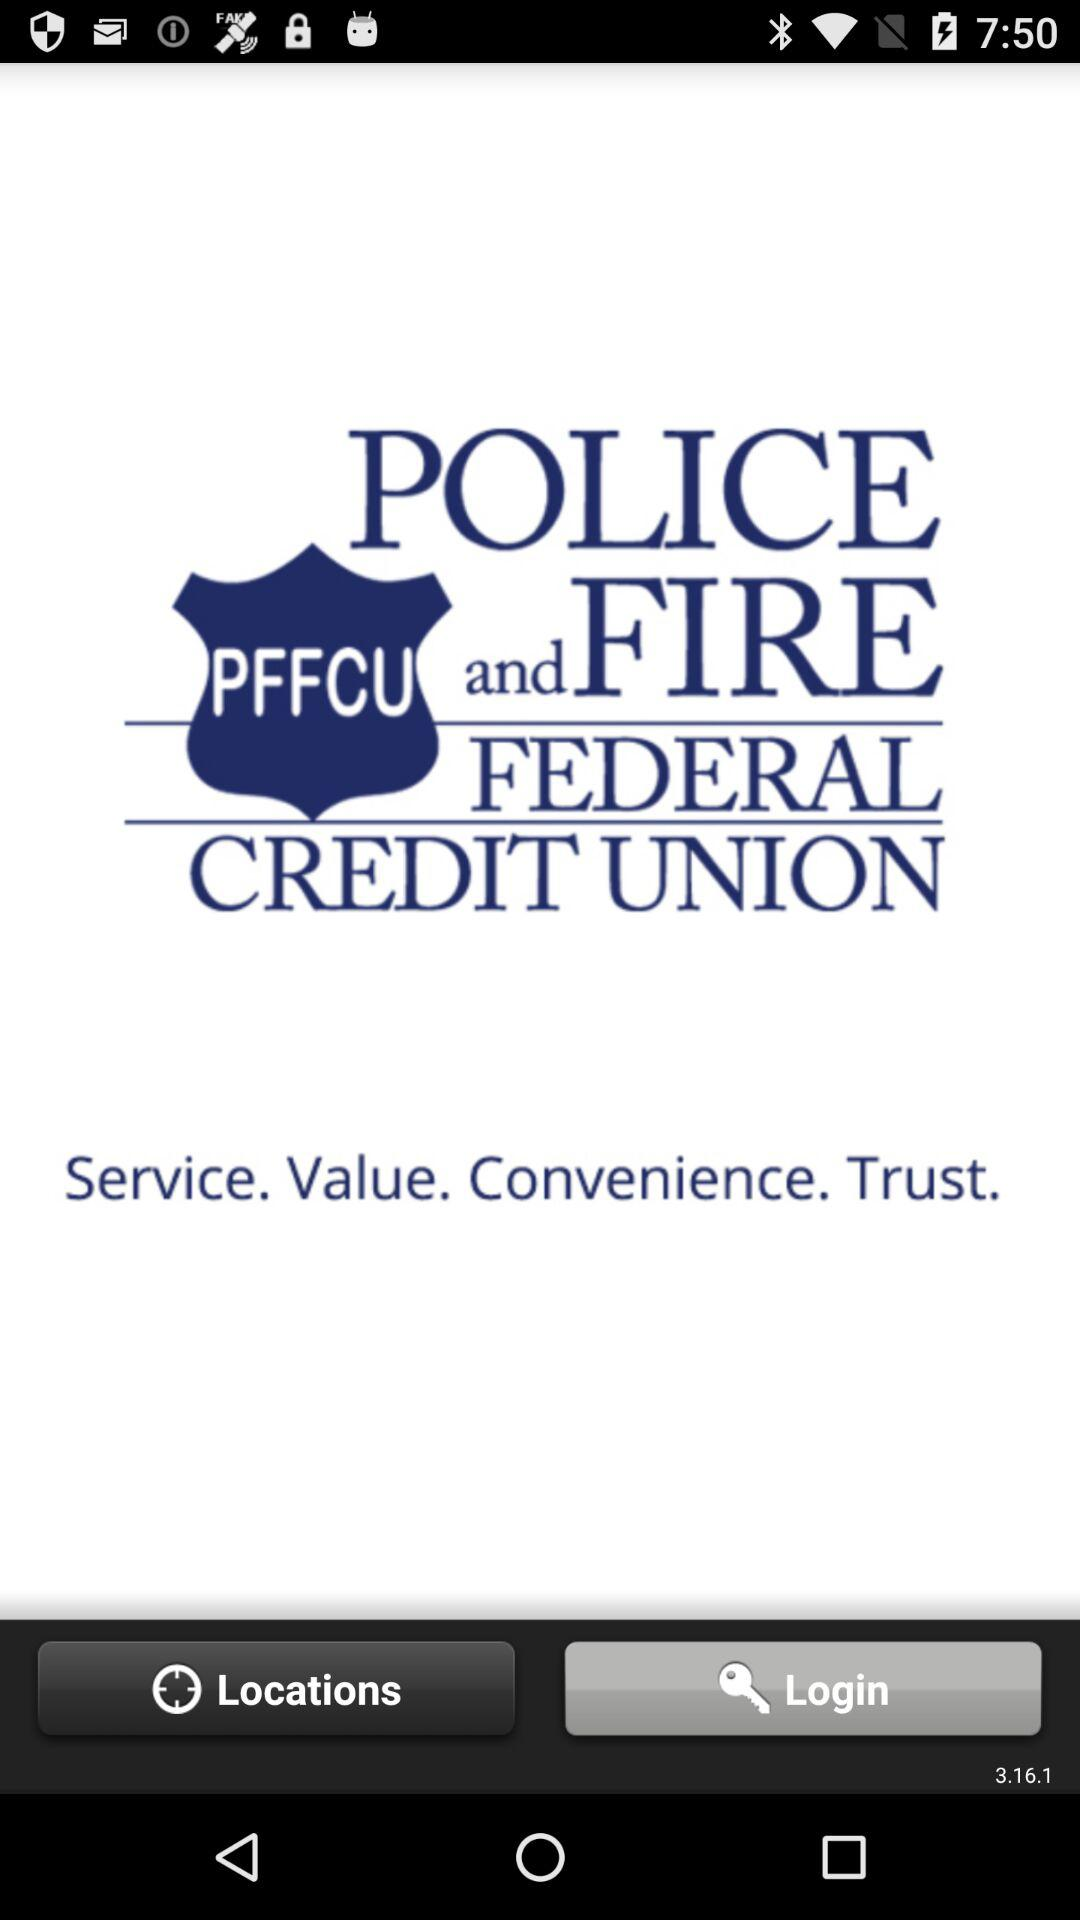What is the application name? The application name is "POLICE and FIRE FEDERAL CREDIT UNION". 